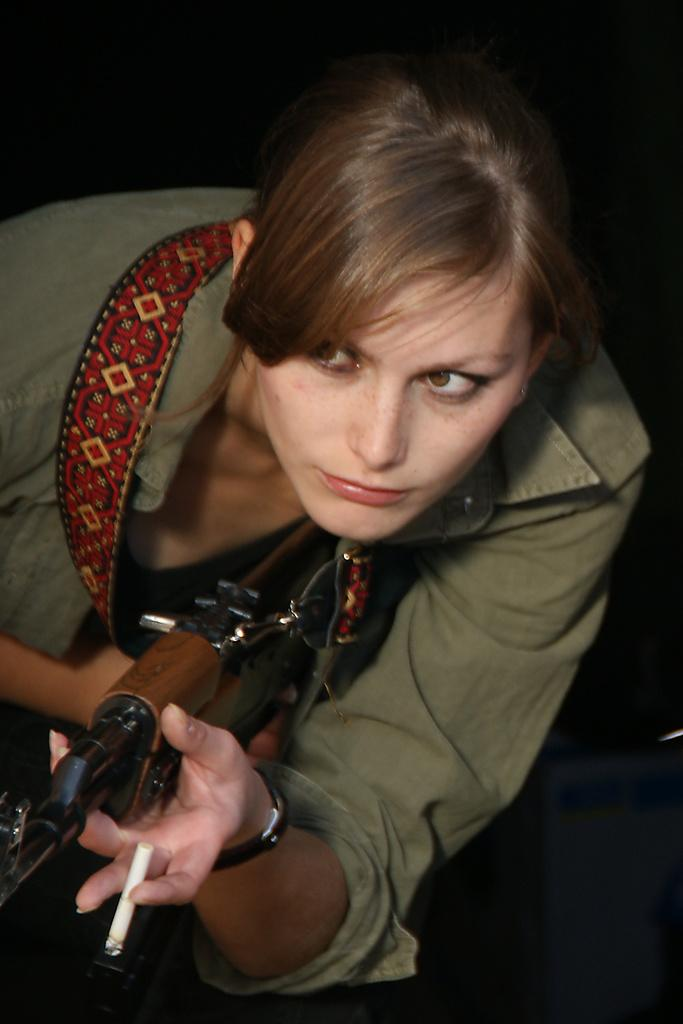Who is the main subject in the image? There is a woman in the image. What is the woman wearing on her wrist? The woman is wearing a watch. What objects is the woman holding in the image? The woman is holding a gun and a cigarette. Can you describe the background of the image? The background of the image is dark. How many sisters are present in the image? There is no mention of sisters in the image, so we cannot determine the number of sisters present. What type of vase can be seen on the table in the image? There is no vase present in the image. 